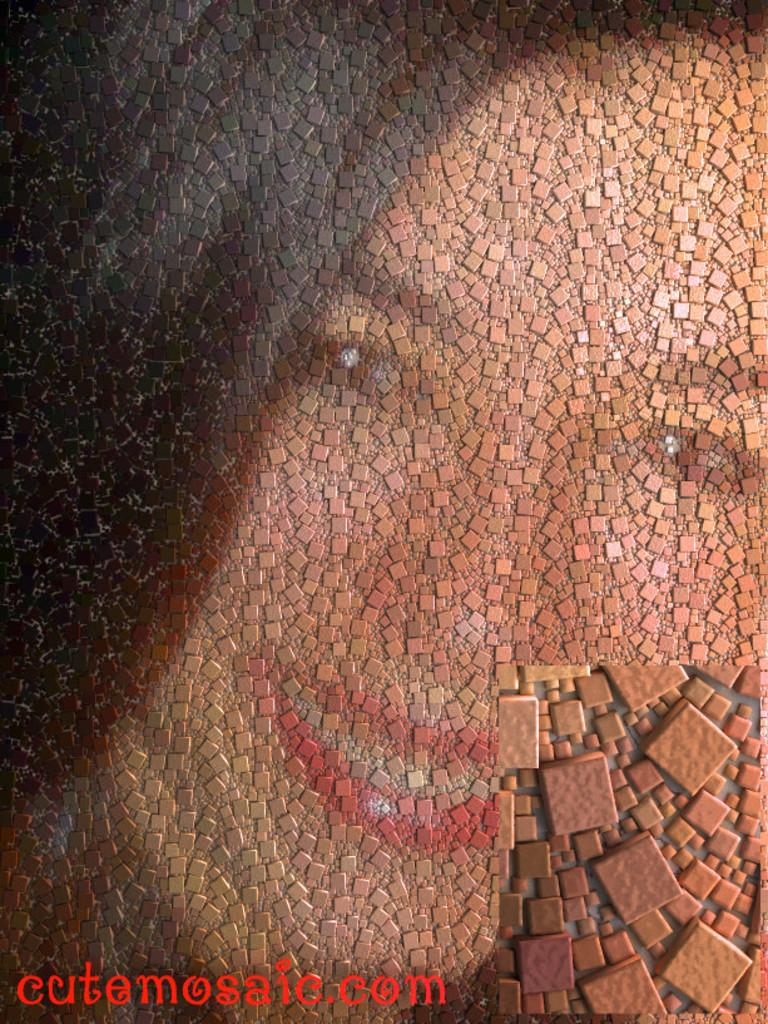What is depicted on the wall in the image? There is a painting of a woman on the wall. Can you describe the woman's expression in the painting? The woman in the painting is smiling. What additional detail can be seen at the bottom of the image? There is text written in red color at the bottom of the image. Is there any indication that the image might have been altered or edited? The image might be edited, as mentioned in the facts. What type of harbor can be seen in the background of the painting? There is no harbor visible in the painting; it only depicts a woman. Is there any grass present in the image? There is no grass visible in the image; it only features a painting of a woman on the wall. 